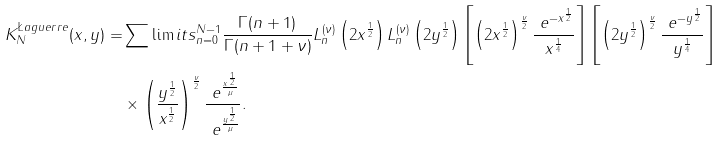<formula> <loc_0><loc_0><loc_500><loc_500>K _ { N } ^ { \L a g u e r r e } ( x , y ) = & \sum \lim i t s _ { n = 0 } ^ { N - 1 } \frac { \Gamma ( n + 1 ) } { \Gamma ( n + 1 + \nu ) } L _ { n } ^ { ( \nu ) } \left ( 2 x ^ { \frac { 1 } { 2 } } \right ) L _ { n } ^ { ( \nu ) } \left ( 2 y ^ { \frac { 1 } { 2 } } \right ) \left [ \left ( 2 x ^ { \frac { 1 } { 2 } } \right ) ^ { \frac { \nu } { 2 } } \frac { \ e ^ { - x ^ { \frac { 1 } { 2 } } } } { x ^ { \frac { 1 } { 4 } } } \right ] \left [ \left ( 2 y ^ { \frac { 1 } { 2 } } \right ) ^ { \frac { \nu } { 2 } } \frac { \ e ^ { - y ^ { \frac { 1 } { 2 } } } } { y ^ { \frac { 1 } { 4 } } } \right ] \\ & \times \left ( \frac { y ^ { \frac { 1 } { 2 } } } { x ^ { \frac { 1 } { 2 } } } \right ) ^ { \frac { \nu } { 2 } } \frac { \ e ^ { \frac { x ^ { \frac { 1 } { 2 } } } { \mu } } } { \ e ^ { \frac { y ^ { \frac { 1 } { 2 } } } { \mu } } } .</formula> 